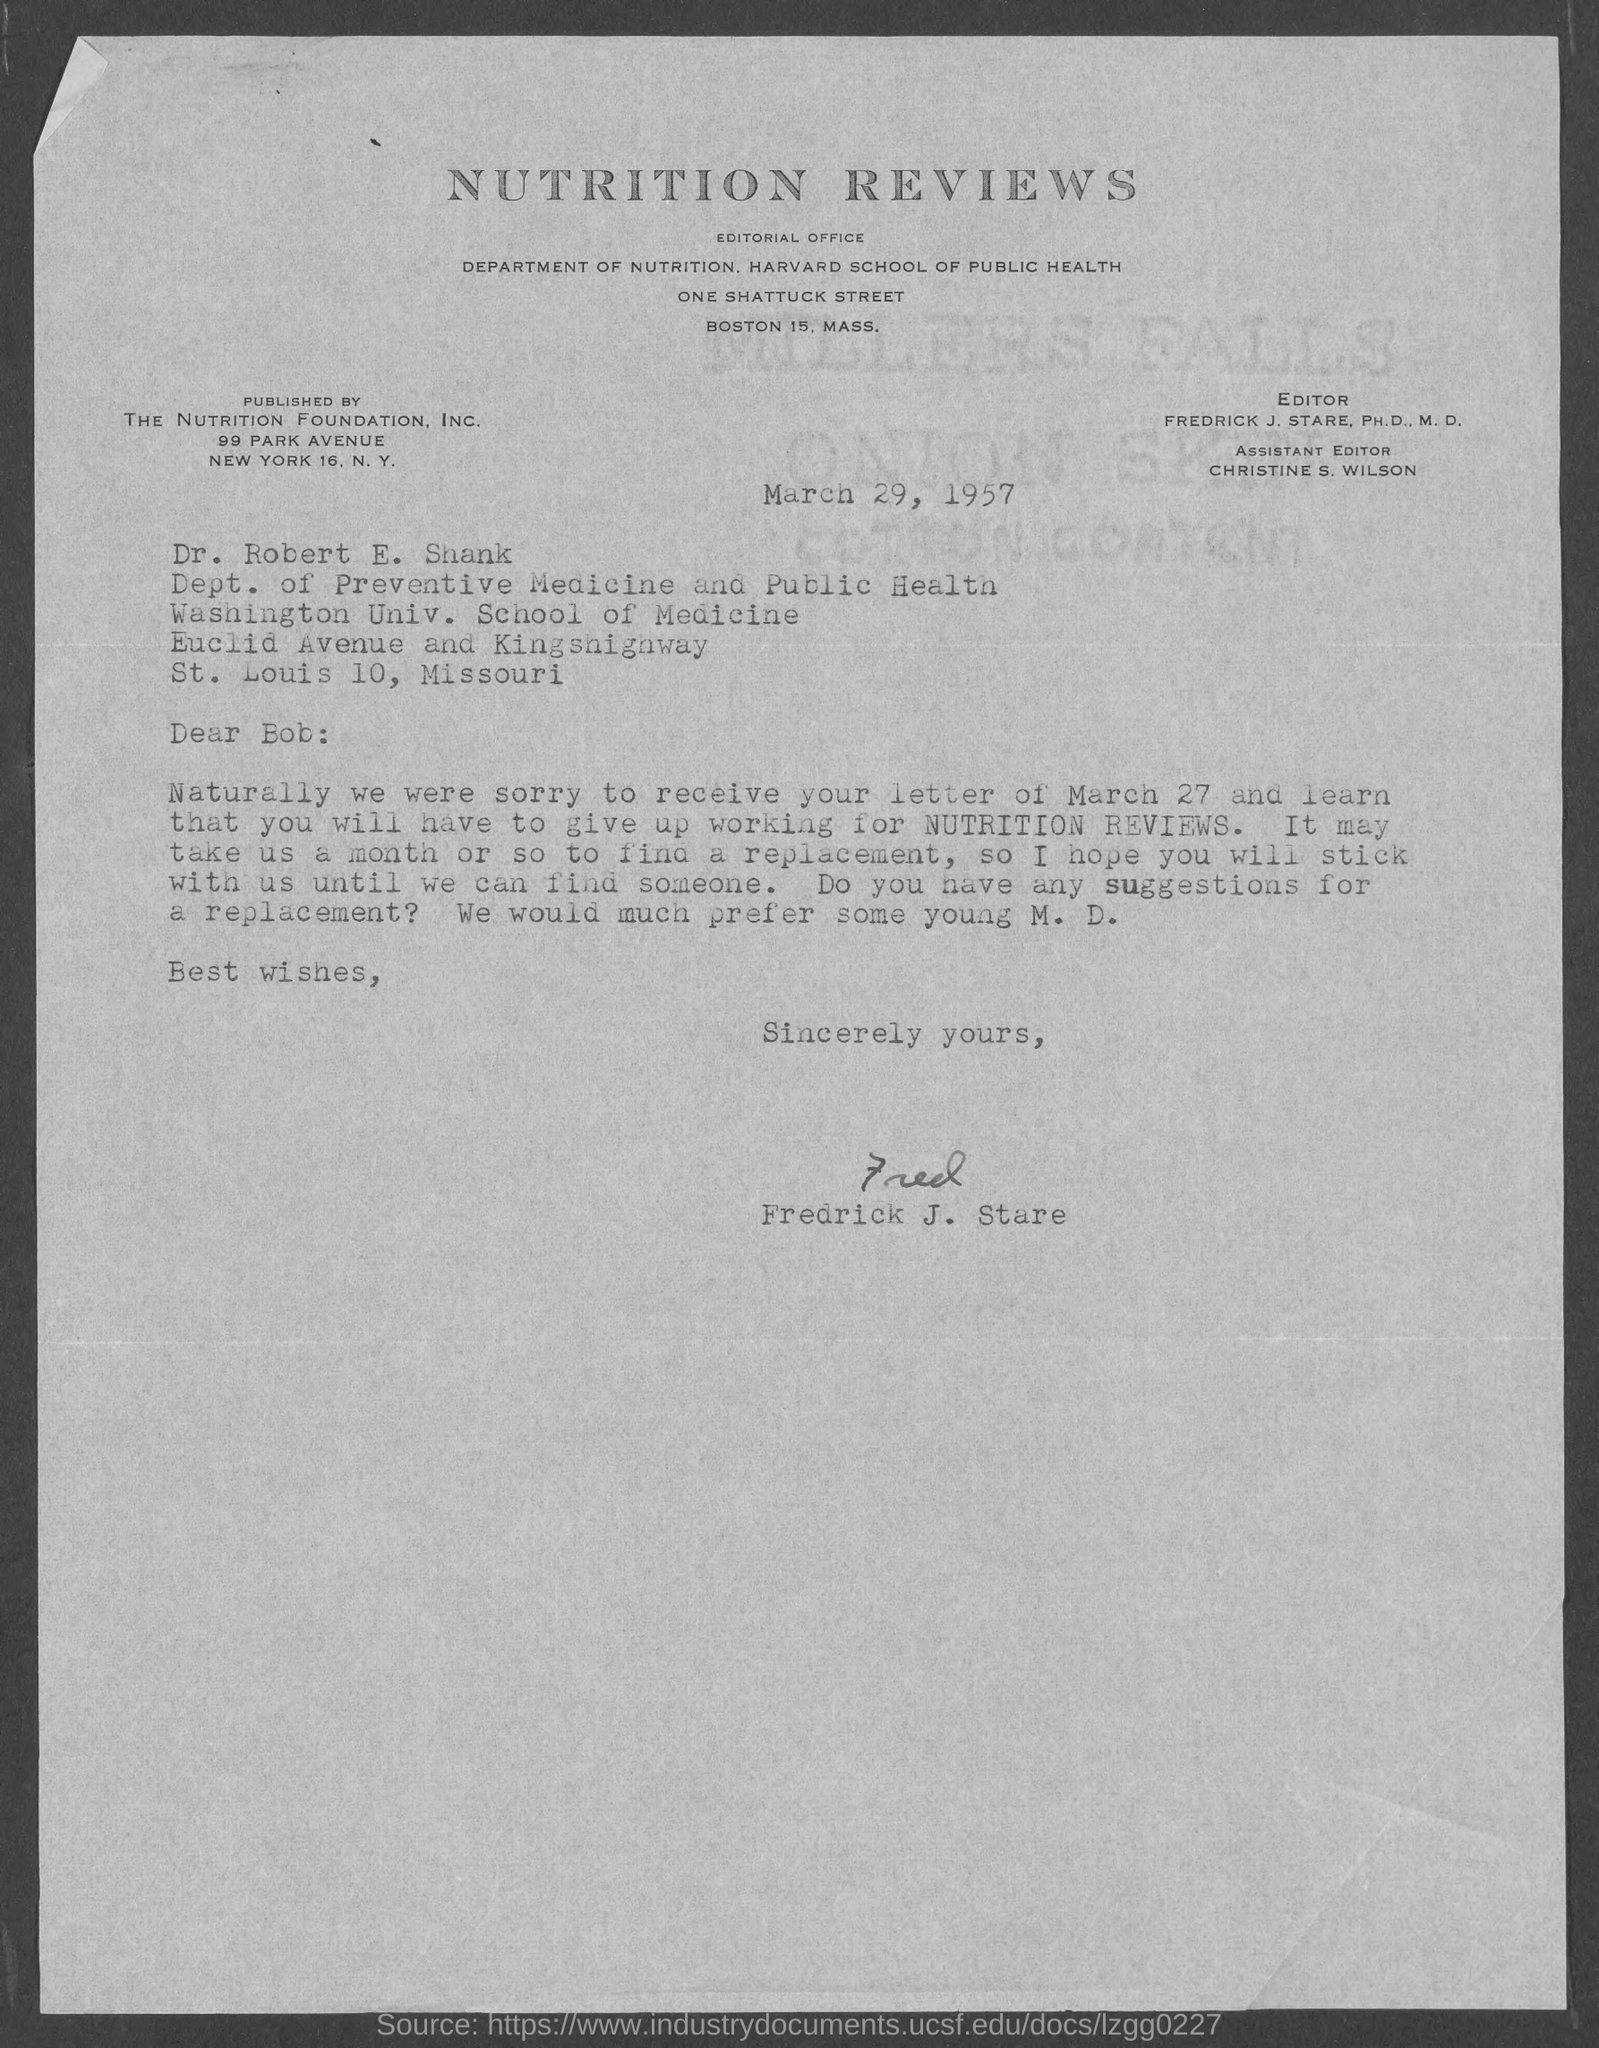Give some essential details in this illustration. This letter is published by the Nutrition Foundation Inc.. Frederick J. Stare, Ph.D., M.D., is the editor of Nutrition Reviews. The assistant editor is Christine S. Wilson. Dr. Robert E. Shank belongs to the Department of Preventive Medicine and Public Health. The letter is written by Frederick J. Stare. 